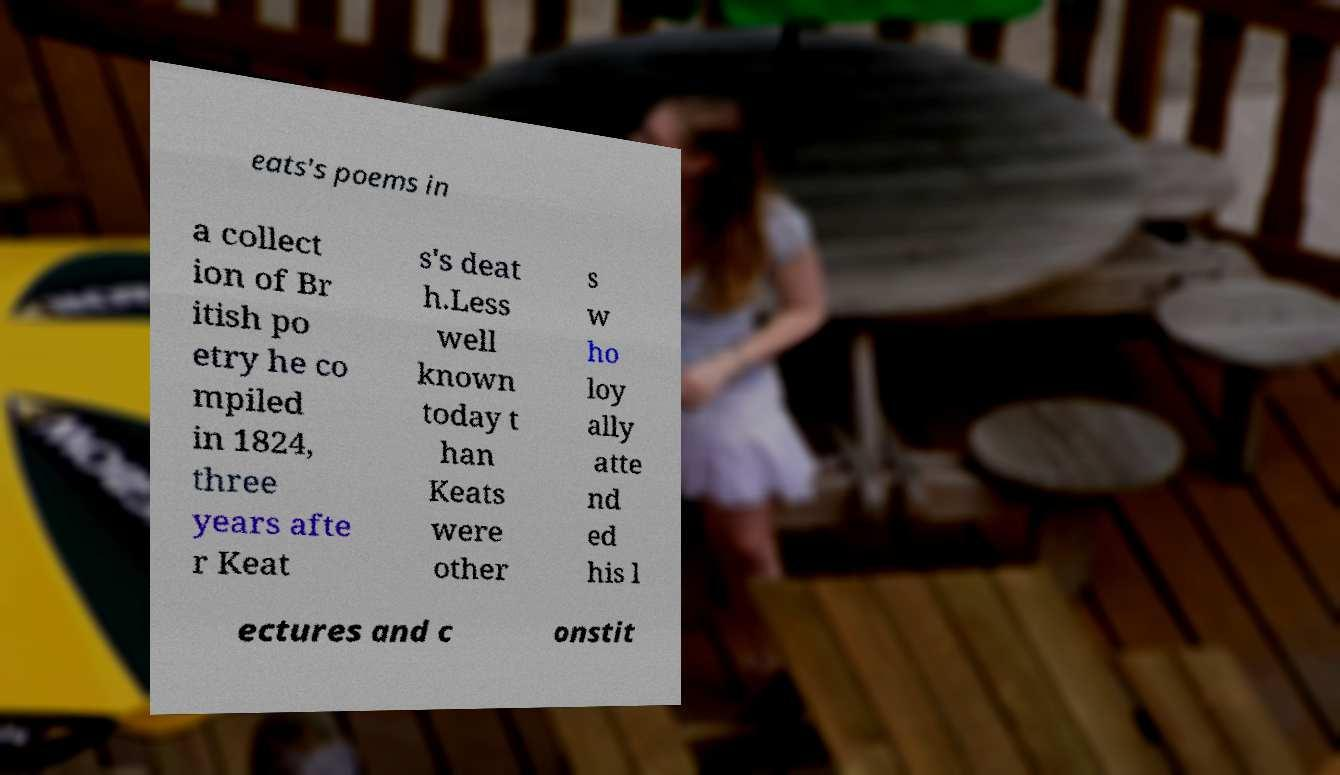For documentation purposes, I need the text within this image transcribed. Could you provide that? eats's poems in a collect ion of Br itish po etry he co mpiled in 1824, three years afte r Keat s's deat h.Less well known today t han Keats were other s w ho loy ally atte nd ed his l ectures and c onstit 